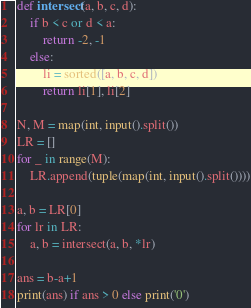Convert code to text. <code><loc_0><loc_0><loc_500><loc_500><_Python_>def intersect(a, b, c, d):
    if b < c or d < a:
        return -2, -1
    else:
        li = sorted([a, b, c, d])
        return li[1], li[2]
        
N, M = map(int, input().split())
LR = []
for _ in range(M):
    LR.append(tuple(map(int, input().split())))
    
a, b = LR[0]
for lr in LR:
    a, b = intersect(a, b, *lr)
    
ans = b-a+1
print(ans) if ans > 0 else print('0')</code> 